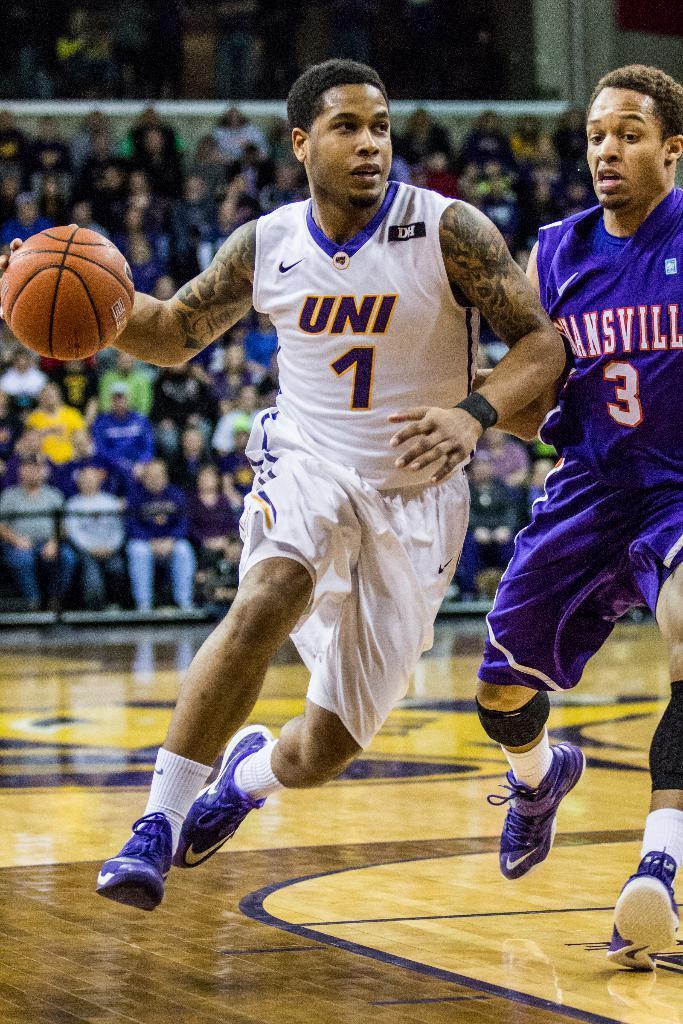Describe this image in one or two sentences. In this image in front there are two people playing a game. At the bottom of the image there is a floor. In the background of the image there are people sitting on the chairs. 